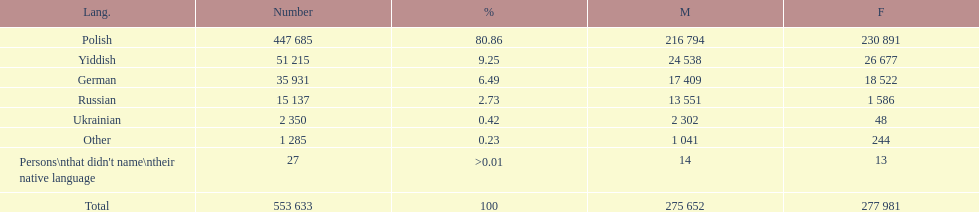Which language did only .42% of people in the imperial census of 1897 speak in the p&#322;ock governorate? Ukrainian. 